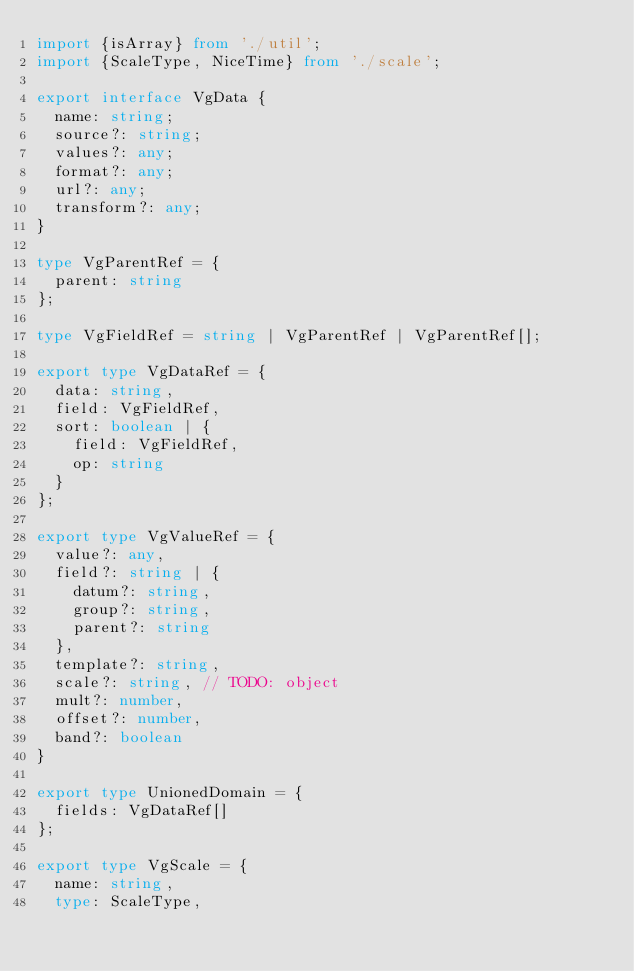<code> <loc_0><loc_0><loc_500><loc_500><_TypeScript_>import {isArray} from './util';
import {ScaleType, NiceTime} from './scale';

export interface VgData {
  name: string;
  source?: string;
  values?: any;
  format?: any;
  url?: any;
  transform?: any;
}

type VgParentRef = {
  parent: string
};

type VgFieldRef = string | VgParentRef | VgParentRef[];

export type VgDataRef = {
  data: string,
  field: VgFieldRef,
  sort: boolean | {
    field: VgFieldRef,
    op: string
  }
};

export type VgValueRef = {
  value?: any,
  field?: string | {
    datum?: string,
    group?: string,
    parent?: string
  },
  template?: string,
  scale?: string, // TODO: object
  mult?: number,
  offset?: number,
  band?: boolean
}

export type UnionedDomain = {
  fields: VgDataRef[]
};

export type VgScale = {
  name: string,
  type: ScaleType,</code> 